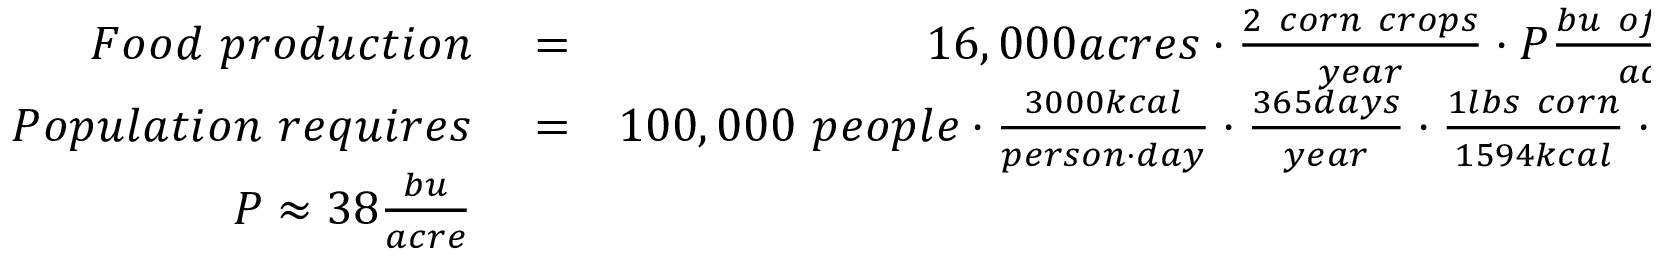Convert formula to latex. <formula><loc_0><loc_0><loc_500><loc_500>\begin{array} { r l r } { F o o d p r o d u c t i o n } & = } & { 1 6 , 0 0 0 a c r e s \cdot \frac { 2 c o r n c r o p s } { y e a r } \cdot P \frac { b u o f c o r n } { a c r e } } \\ { P o p u l a t i o n r e q u i r e s } & = } & { 1 0 0 , 0 0 0 p e o p l e \cdot \frac { 3 0 0 0 k c a l } { p e r s o n \cdot d a y } \cdot \frac { 3 6 5 d a y s } { y e a r } \cdot \frac { 1 l b s c o r n } { 1 5 9 4 k c a l } \cdot \frac { 1 b u } { 5 6 l b s } } \\ { P \approx 3 8 \frac { b u } { a c r e } } \end{array}</formula> 